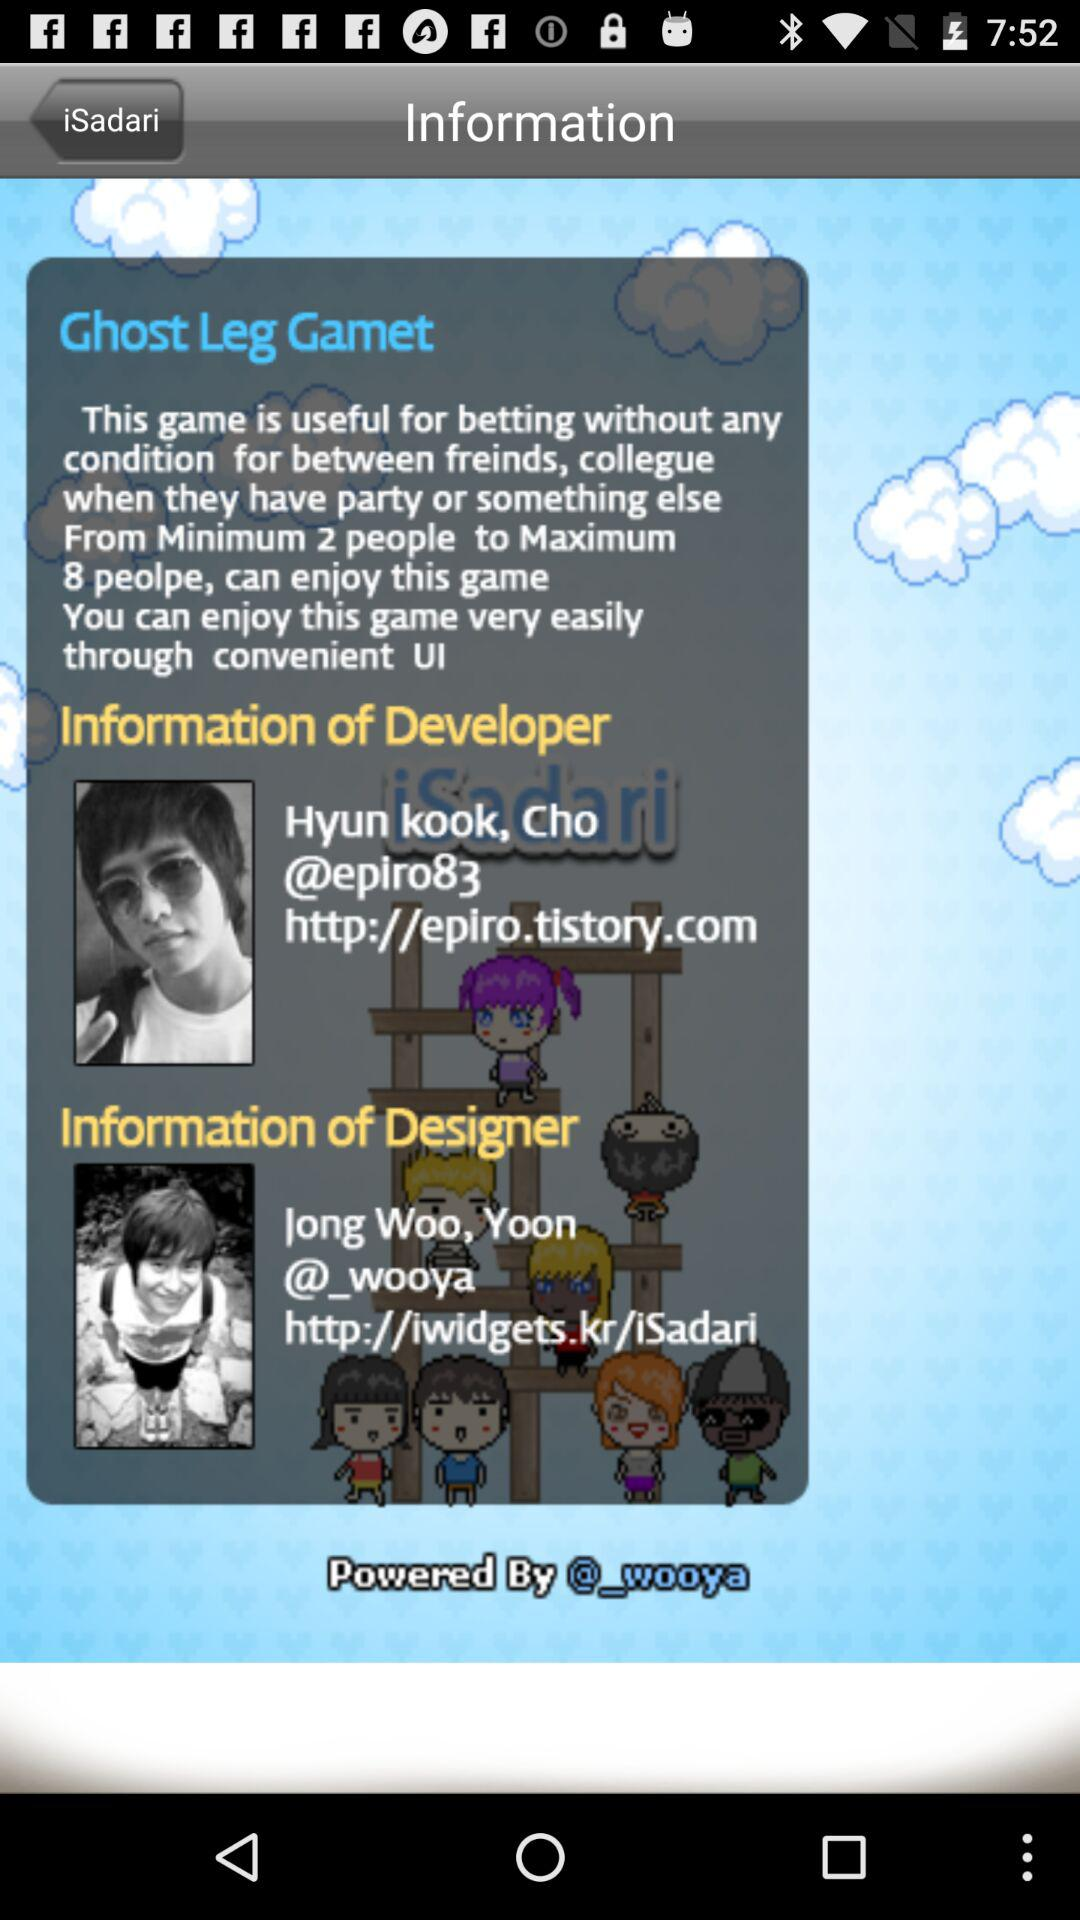Who is the designer? The designer is Jong Woo. 